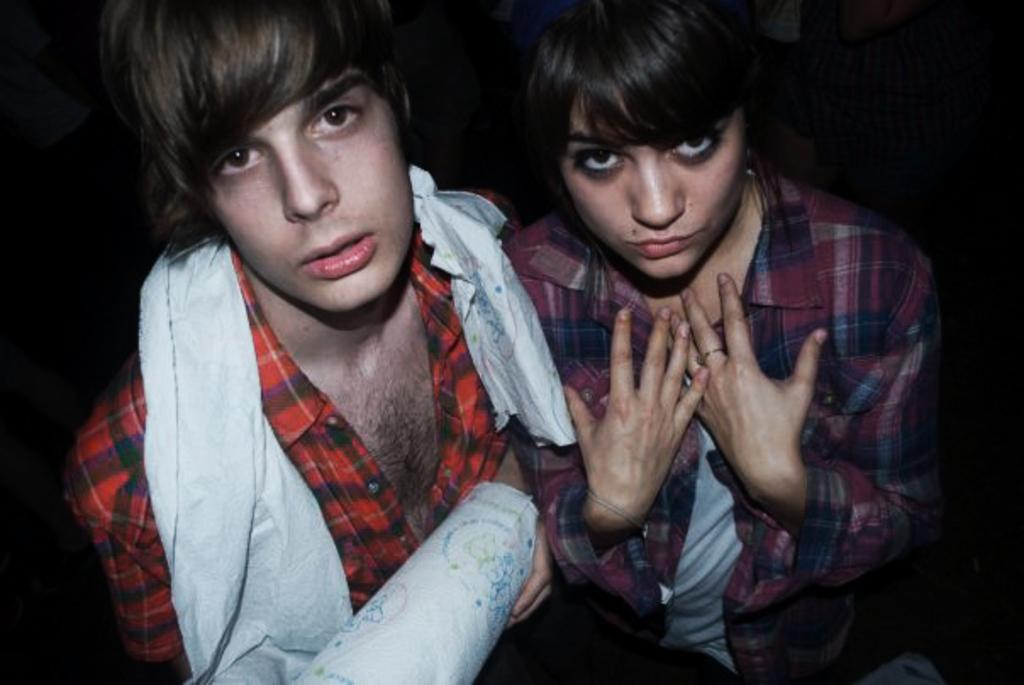How many people are present in the image? There are two people in the image, a man and a woman. Can you describe the individuals in the image? The image features a man and a woman. What might the man and woman be doing in the image? The specific activity of the man and woman cannot be determined from the provided facts. What is the title of the vessel that the governor is riding in the image? There is no vessel or governor present in the image; it features a man and a woman. 